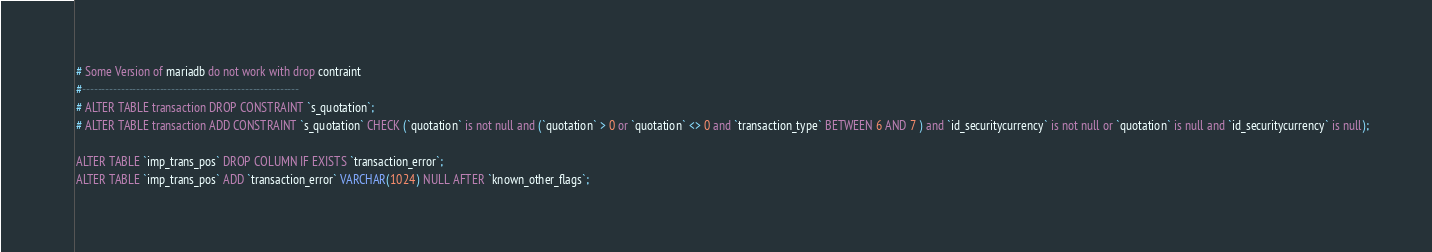<code> <loc_0><loc_0><loc_500><loc_500><_SQL_># Some Version of mariadb do not work with drop contraint
#--------------------------------------------------------
# ALTER TABLE transaction DROP CONSTRAINT `s_quotation`;
# ALTER TABLE transaction ADD CONSTRAINT `s_quotation` CHECK (`quotation` is not null and (`quotation` > 0 or `quotation` <> 0 and `transaction_type` BETWEEN 6 AND 7 ) and `id_securitycurrency` is not null or `quotation` is null and `id_securitycurrency` is null);

ALTER TABLE `imp_trans_pos` DROP COLUMN IF EXISTS `transaction_error`;
ALTER TABLE `imp_trans_pos` ADD `transaction_error` VARCHAR(1024) NULL AFTER `known_other_flags`; </code> 